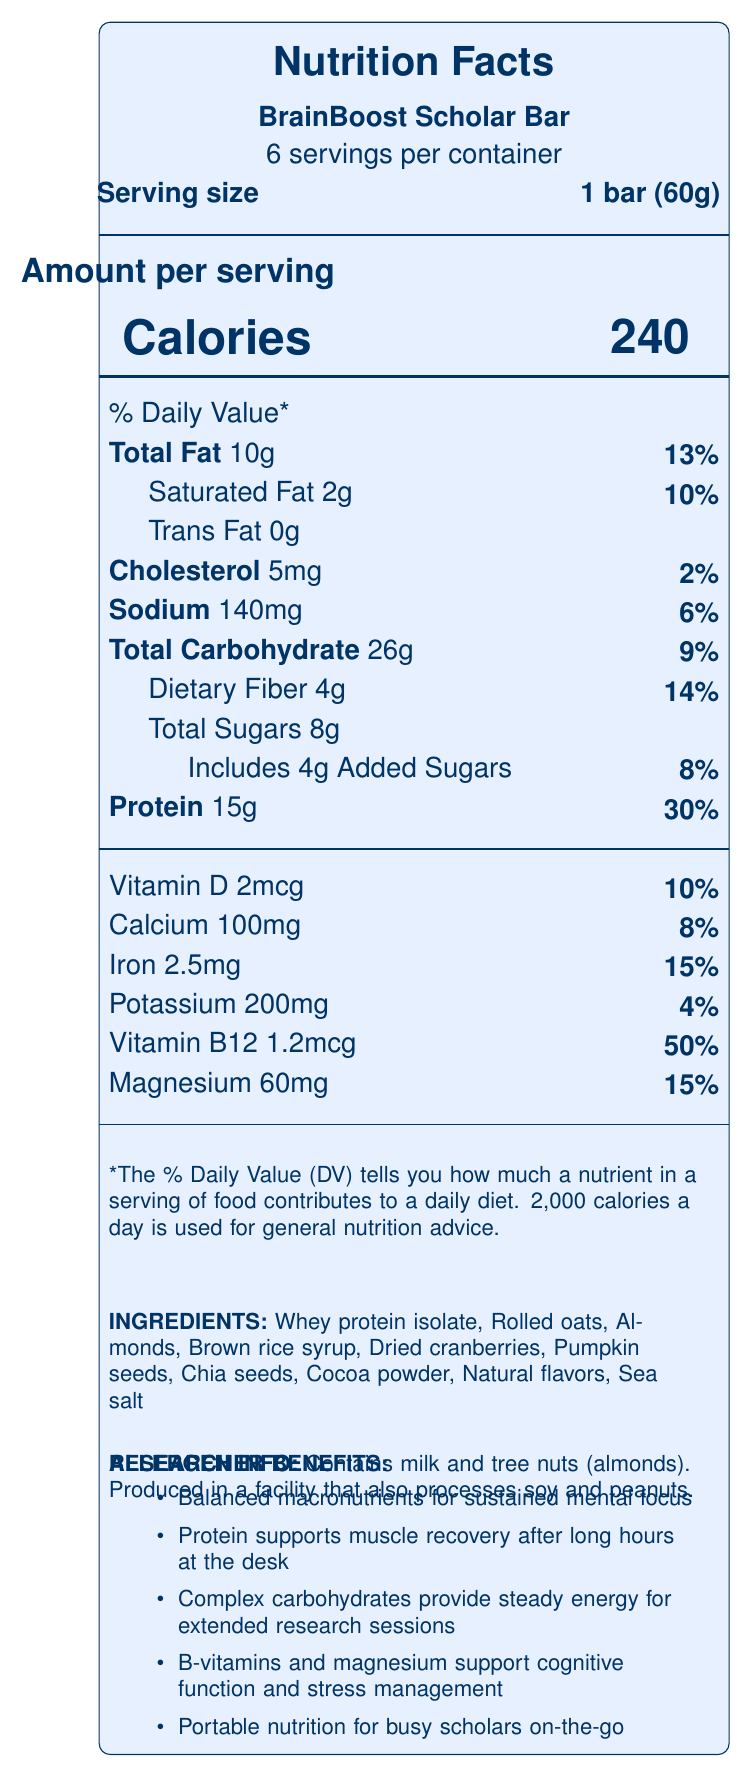what is the serving size of the BrainBoost Scholar Bar? The serving size is clearly stated as "1 bar (60g)" in the document.
Answer: 1 bar (60g) how many calories are in one serving of the BrainBoost Scholar Bar? The document specifies that each serving contains 240 calories.
Answer: 240 calories what percentage of the Daily Value for protein does one serving provide? According to the document, one serving provides 30% of the Daily Value for protein.
Answer: 30% what ingredients are contained in the BrainBoost Scholar Bar? The document lists the ingredients explicitly.
Answer: Whey protein isolate, Rolled oats, Almonds, Brown rice syrup, Dried cranberries, Pumpkin seeds, Chia seeds, Cocoa powder, Natural flavors, Sea salt how much dietary fiber is in one serving, and what percentage of the Daily Value does it represent? The document mentions that one serving contains 4g of dietary fiber, accounting for 14% of the Daily Value.
Answer: 4g, 14% does the BrainBoost Scholar Bar contain any trans fat? The document states that there are 0g of trans fat in the bar.
Answer: No what is the total amount of sugars in one serving, and how much of it is added sugar? The document specifies 8g of total sugars with 4g being added sugars.
Answer: 8g total sugars, 4g added sugars which vitamin is provided at 50% of the Daily Value per serving? A. Vitamin D B. Vitamin B12 C. Vitamin C D. Vitamin A The document indicates that Vitamin B12 is provided at 50% of the Daily Value per serving.
Answer: B which nutrient has the highest percentage of the Daily Value in one serving? A. Protein B. Vitamin D C. Calcium D. Sodium Protein has the highest percentage of the Daily Value in one serving at 30%.
Answer: A is the BrainBoost Scholar Bar suitable for someone with a peanut allergy? The document states that the bar is produced in a facility that also processes peanuts, meaning it poses a potential risk for those with peanut allergies.
Answer: No explain the main purpose of the BrainBoost Scholar Bar based on the document The document emphasizes its purpose of supporting cognitive function and sustained energy for scholars, highlighting various nutritional benefits.
Answer: The BrainBoost Scholar Bar is formulated to support long hours of study and research by providing sustained energy release and nutritional benefits. It includes balanced macronutrients, protein for muscle recovery, complex carbohydrates for steady energy, and vitamins to support cognitive function and stress management. what is the price of the BrainBoost Scholar Bar? The document does not provide any details about the price of the BrainBoost Scholar Bar.
Answer: Not enough information 